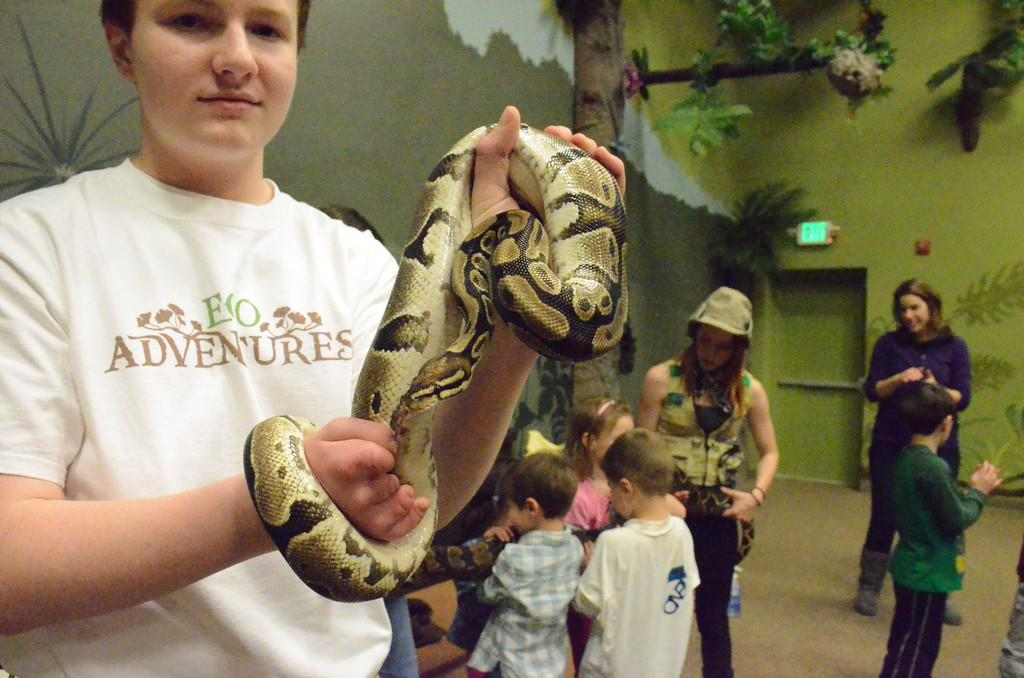What is the main subject of the image? There is a boy in the image. What is the boy doing in the image? The boy is holding a snake with both hands. Are there any other people in the image? Yes, there are other children behind the boy. What can be seen in the background of the image? There is a tree in the backdrop of the image. What is located on the right side of the image? There is a door on the right side of the image. What type of blade is being used by the police officer in the image? There is no police officer or blade present in the image. 